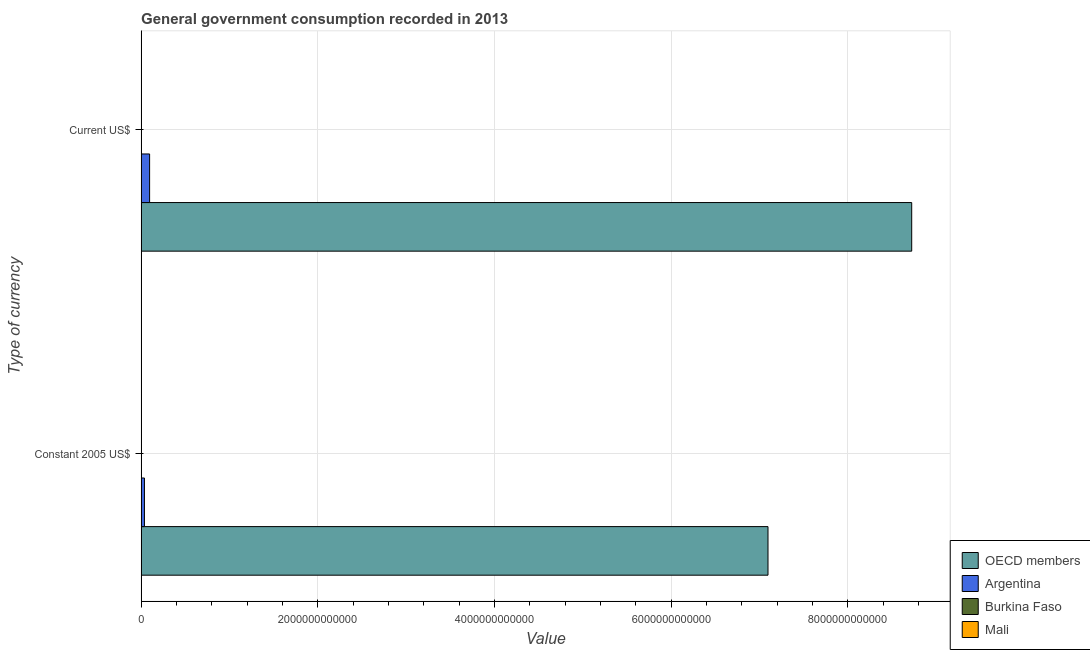How many groups of bars are there?
Offer a terse response. 2. What is the label of the 1st group of bars from the top?
Provide a succinct answer. Current US$. What is the value consumed in current us$ in Burkina Faso?
Your answer should be compact. 2.51e+09. Across all countries, what is the maximum value consumed in constant 2005 us$?
Your answer should be compact. 7.10e+12. Across all countries, what is the minimum value consumed in current us$?
Provide a succinct answer. 1.92e+09. In which country was the value consumed in constant 2005 us$ maximum?
Your response must be concise. OECD members. In which country was the value consumed in constant 2005 us$ minimum?
Your answer should be compact. Mali. What is the total value consumed in constant 2005 us$ in the graph?
Your answer should be very brief. 7.14e+12. What is the difference between the value consumed in constant 2005 us$ in Burkina Faso and that in OECD members?
Ensure brevity in your answer.  -7.09e+12. What is the difference between the value consumed in constant 2005 us$ in Burkina Faso and the value consumed in current us$ in Argentina?
Offer a terse response. -9.42e+1. What is the average value consumed in constant 2005 us$ per country?
Your answer should be very brief. 1.78e+12. What is the difference between the value consumed in current us$ and value consumed in constant 2005 us$ in Argentina?
Offer a very short reply. 5.83e+1. In how many countries, is the value consumed in current us$ greater than 7200000000000 ?
Your response must be concise. 1. What is the ratio of the value consumed in constant 2005 us$ in Burkina Faso to that in Mali?
Give a very brief answer. 1.17. Is the value consumed in current us$ in Argentina less than that in Burkina Faso?
Provide a succinct answer. No. What does the 1st bar from the top in Current US$ represents?
Provide a succinct answer. Mali. What does the 2nd bar from the bottom in Current US$ represents?
Your answer should be very brief. Argentina. What is the difference between two consecutive major ticks on the X-axis?
Offer a very short reply. 2.00e+12. Are the values on the major ticks of X-axis written in scientific E-notation?
Keep it short and to the point. No. How many legend labels are there?
Keep it short and to the point. 4. What is the title of the graph?
Your answer should be compact. General government consumption recorded in 2013. What is the label or title of the X-axis?
Give a very brief answer. Value. What is the label or title of the Y-axis?
Give a very brief answer. Type of currency. What is the Value of OECD members in Constant 2005 US$?
Make the answer very short. 7.10e+12. What is the Value of Argentina in Constant 2005 US$?
Provide a succinct answer. 3.75e+1. What is the Value of Burkina Faso in Constant 2005 US$?
Provide a succinct answer. 1.55e+09. What is the Value of Mali in Constant 2005 US$?
Offer a terse response. 1.33e+09. What is the Value of OECD members in Current US$?
Provide a short and direct response. 8.72e+12. What is the Value in Argentina in Current US$?
Provide a succinct answer. 9.57e+1. What is the Value of Burkina Faso in Current US$?
Offer a terse response. 2.51e+09. What is the Value of Mali in Current US$?
Your answer should be very brief. 1.92e+09. Across all Type of currency, what is the maximum Value of OECD members?
Provide a short and direct response. 8.72e+12. Across all Type of currency, what is the maximum Value in Argentina?
Keep it short and to the point. 9.57e+1. Across all Type of currency, what is the maximum Value of Burkina Faso?
Your response must be concise. 2.51e+09. Across all Type of currency, what is the maximum Value in Mali?
Your answer should be compact. 1.92e+09. Across all Type of currency, what is the minimum Value of OECD members?
Keep it short and to the point. 7.10e+12. Across all Type of currency, what is the minimum Value in Argentina?
Make the answer very short. 3.75e+1. Across all Type of currency, what is the minimum Value of Burkina Faso?
Make the answer very short. 1.55e+09. Across all Type of currency, what is the minimum Value in Mali?
Make the answer very short. 1.33e+09. What is the total Value in OECD members in the graph?
Offer a very short reply. 1.58e+13. What is the total Value of Argentina in the graph?
Give a very brief answer. 1.33e+11. What is the total Value in Burkina Faso in the graph?
Your answer should be compact. 4.07e+09. What is the total Value of Mali in the graph?
Your answer should be compact. 3.25e+09. What is the difference between the Value of OECD members in Constant 2005 US$ and that in Current US$?
Ensure brevity in your answer.  -1.63e+12. What is the difference between the Value in Argentina in Constant 2005 US$ and that in Current US$?
Your response must be concise. -5.83e+1. What is the difference between the Value in Burkina Faso in Constant 2005 US$ and that in Current US$?
Offer a very short reply. -9.61e+08. What is the difference between the Value in Mali in Constant 2005 US$ and that in Current US$?
Provide a succinct answer. -5.91e+08. What is the difference between the Value in OECD members in Constant 2005 US$ and the Value in Argentina in Current US$?
Your response must be concise. 7.00e+12. What is the difference between the Value of OECD members in Constant 2005 US$ and the Value of Burkina Faso in Current US$?
Your response must be concise. 7.09e+12. What is the difference between the Value in OECD members in Constant 2005 US$ and the Value in Mali in Current US$?
Your answer should be very brief. 7.09e+12. What is the difference between the Value in Argentina in Constant 2005 US$ and the Value in Burkina Faso in Current US$?
Your answer should be very brief. 3.49e+1. What is the difference between the Value in Argentina in Constant 2005 US$ and the Value in Mali in Current US$?
Provide a short and direct response. 3.55e+1. What is the difference between the Value of Burkina Faso in Constant 2005 US$ and the Value of Mali in Current US$?
Offer a very short reply. -3.68e+08. What is the average Value of OECD members per Type of currency?
Offer a very short reply. 7.91e+12. What is the average Value in Argentina per Type of currency?
Keep it short and to the point. 6.66e+1. What is the average Value in Burkina Faso per Type of currency?
Give a very brief answer. 2.03e+09. What is the average Value in Mali per Type of currency?
Offer a terse response. 1.62e+09. What is the difference between the Value in OECD members and Value in Argentina in Constant 2005 US$?
Provide a short and direct response. 7.06e+12. What is the difference between the Value in OECD members and Value in Burkina Faso in Constant 2005 US$?
Ensure brevity in your answer.  7.09e+12. What is the difference between the Value of OECD members and Value of Mali in Constant 2005 US$?
Your answer should be compact. 7.10e+12. What is the difference between the Value in Argentina and Value in Burkina Faso in Constant 2005 US$?
Your response must be concise. 3.59e+1. What is the difference between the Value in Argentina and Value in Mali in Constant 2005 US$?
Make the answer very short. 3.61e+1. What is the difference between the Value in Burkina Faso and Value in Mali in Constant 2005 US$?
Give a very brief answer. 2.23e+08. What is the difference between the Value in OECD members and Value in Argentina in Current US$?
Give a very brief answer. 8.63e+12. What is the difference between the Value in OECD members and Value in Burkina Faso in Current US$?
Your response must be concise. 8.72e+12. What is the difference between the Value of OECD members and Value of Mali in Current US$?
Provide a succinct answer. 8.72e+12. What is the difference between the Value in Argentina and Value in Burkina Faso in Current US$?
Keep it short and to the point. 9.32e+1. What is the difference between the Value of Argentina and Value of Mali in Current US$?
Provide a short and direct response. 9.38e+1. What is the difference between the Value in Burkina Faso and Value in Mali in Current US$?
Offer a very short reply. 5.94e+08. What is the ratio of the Value of OECD members in Constant 2005 US$ to that in Current US$?
Offer a very short reply. 0.81. What is the ratio of the Value of Argentina in Constant 2005 US$ to that in Current US$?
Keep it short and to the point. 0.39. What is the ratio of the Value in Burkina Faso in Constant 2005 US$ to that in Current US$?
Offer a terse response. 0.62. What is the ratio of the Value in Mali in Constant 2005 US$ to that in Current US$?
Offer a terse response. 0.69. What is the difference between the highest and the second highest Value of OECD members?
Provide a succinct answer. 1.63e+12. What is the difference between the highest and the second highest Value of Argentina?
Provide a succinct answer. 5.83e+1. What is the difference between the highest and the second highest Value of Burkina Faso?
Provide a succinct answer. 9.61e+08. What is the difference between the highest and the second highest Value in Mali?
Keep it short and to the point. 5.91e+08. What is the difference between the highest and the lowest Value of OECD members?
Ensure brevity in your answer.  1.63e+12. What is the difference between the highest and the lowest Value of Argentina?
Ensure brevity in your answer.  5.83e+1. What is the difference between the highest and the lowest Value of Burkina Faso?
Make the answer very short. 9.61e+08. What is the difference between the highest and the lowest Value in Mali?
Your answer should be very brief. 5.91e+08. 